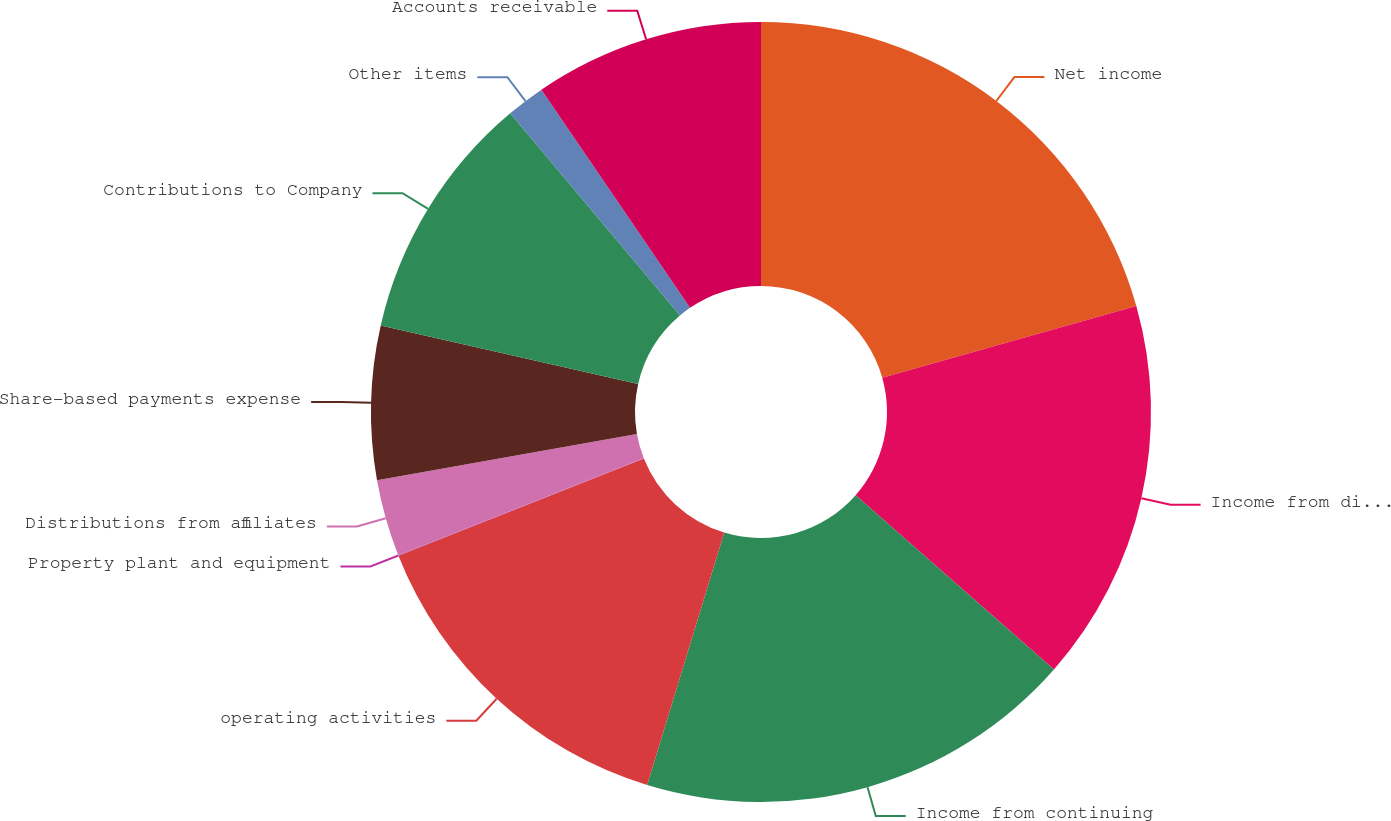Convert chart. <chart><loc_0><loc_0><loc_500><loc_500><pie_chart><fcel>Net income<fcel>Income from discontinued<fcel>Income from continuing<fcel>operating activities<fcel>Property plant and equipment<fcel>Distributions from affiliates<fcel>Share-based payments expense<fcel>Contributions to Company<fcel>Other items<fcel>Accounts receivable<nl><fcel>20.62%<fcel>15.86%<fcel>18.24%<fcel>14.28%<fcel>0.02%<fcel>3.19%<fcel>6.36%<fcel>10.32%<fcel>1.6%<fcel>9.52%<nl></chart> 